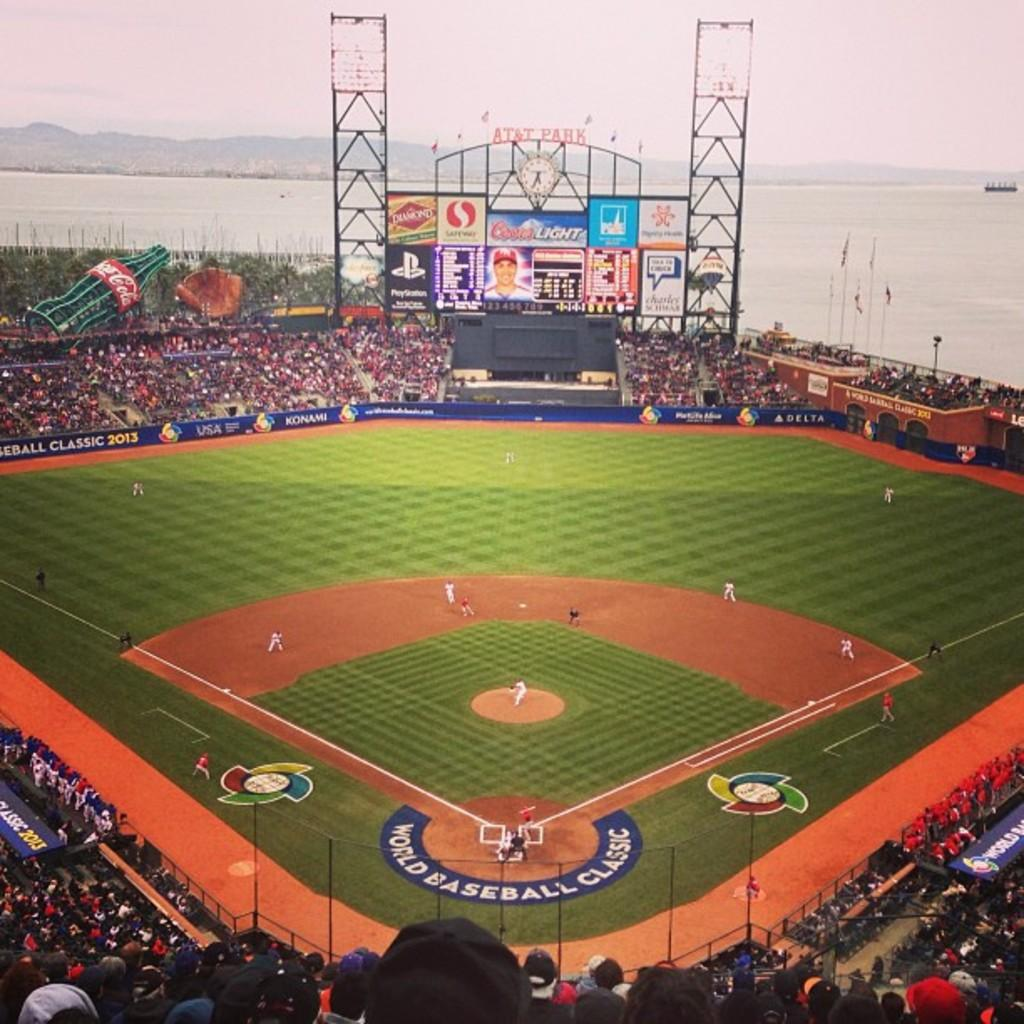<image>
Render a clear and concise summary of the photo. The game being played here is the World Baseball Classic 